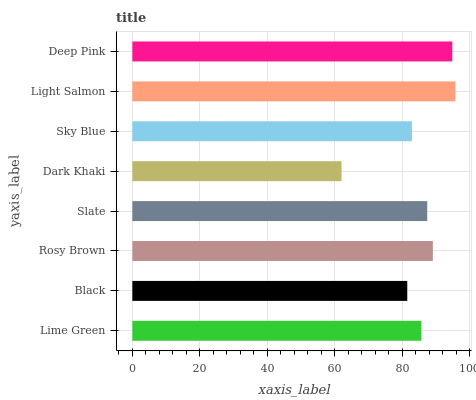Is Dark Khaki the minimum?
Answer yes or no. Yes. Is Light Salmon the maximum?
Answer yes or no. Yes. Is Black the minimum?
Answer yes or no. No. Is Black the maximum?
Answer yes or no. No. Is Lime Green greater than Black?
Answer yes or no. Yes. Is Black less than Lime Green?
Answer yes or no. Yes. Is Black greater than Lime Green?
Answer yes or no. No. Is Lime Green less than Black?
Answer yes or no. No. Is Slate the high median?
Answer yes or no. Yes. Is Lime Green the low median?
Answer yes or no. Yes. Is Rosy Brown the high median?
Answer yes or no. No. Is Dark Khaki the low median?
Answer yes or no. No. 